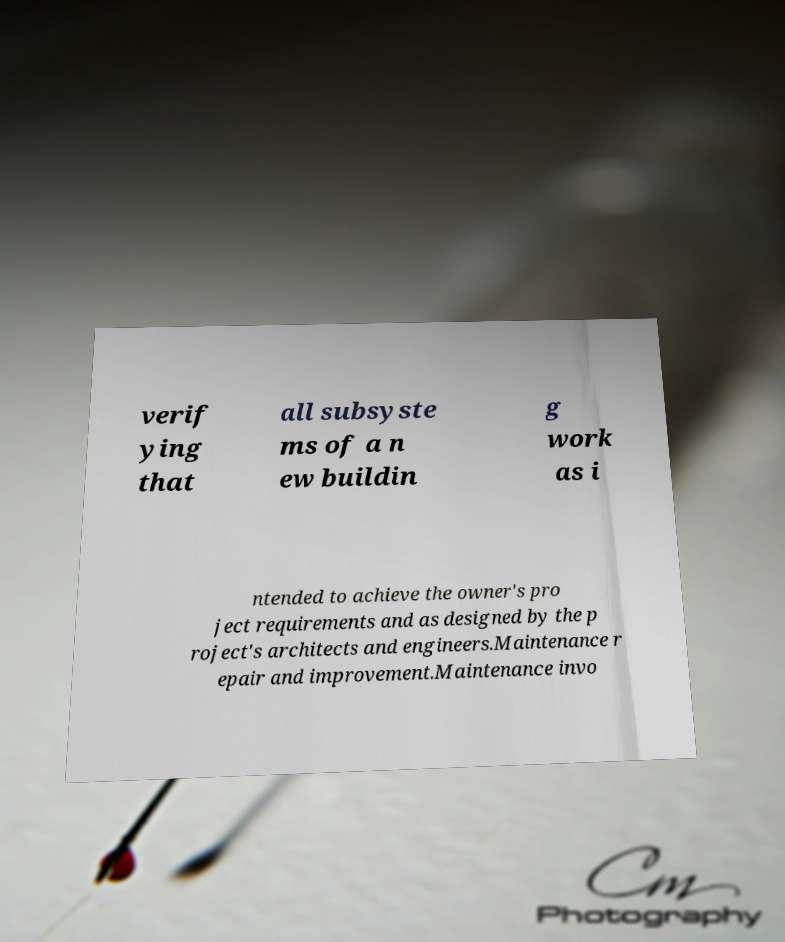Can you read and provide the text displayed in the image?This photo seems to have some interesting text. Can you extract and type it out for me? verif ying that all subsyste ms of a n ew buildin g work as i ntended to achieve the owner's pro ject requirements and as designed by the p roject's architects and engineers.Maintenance r epair and improvement.Maintenance invo 